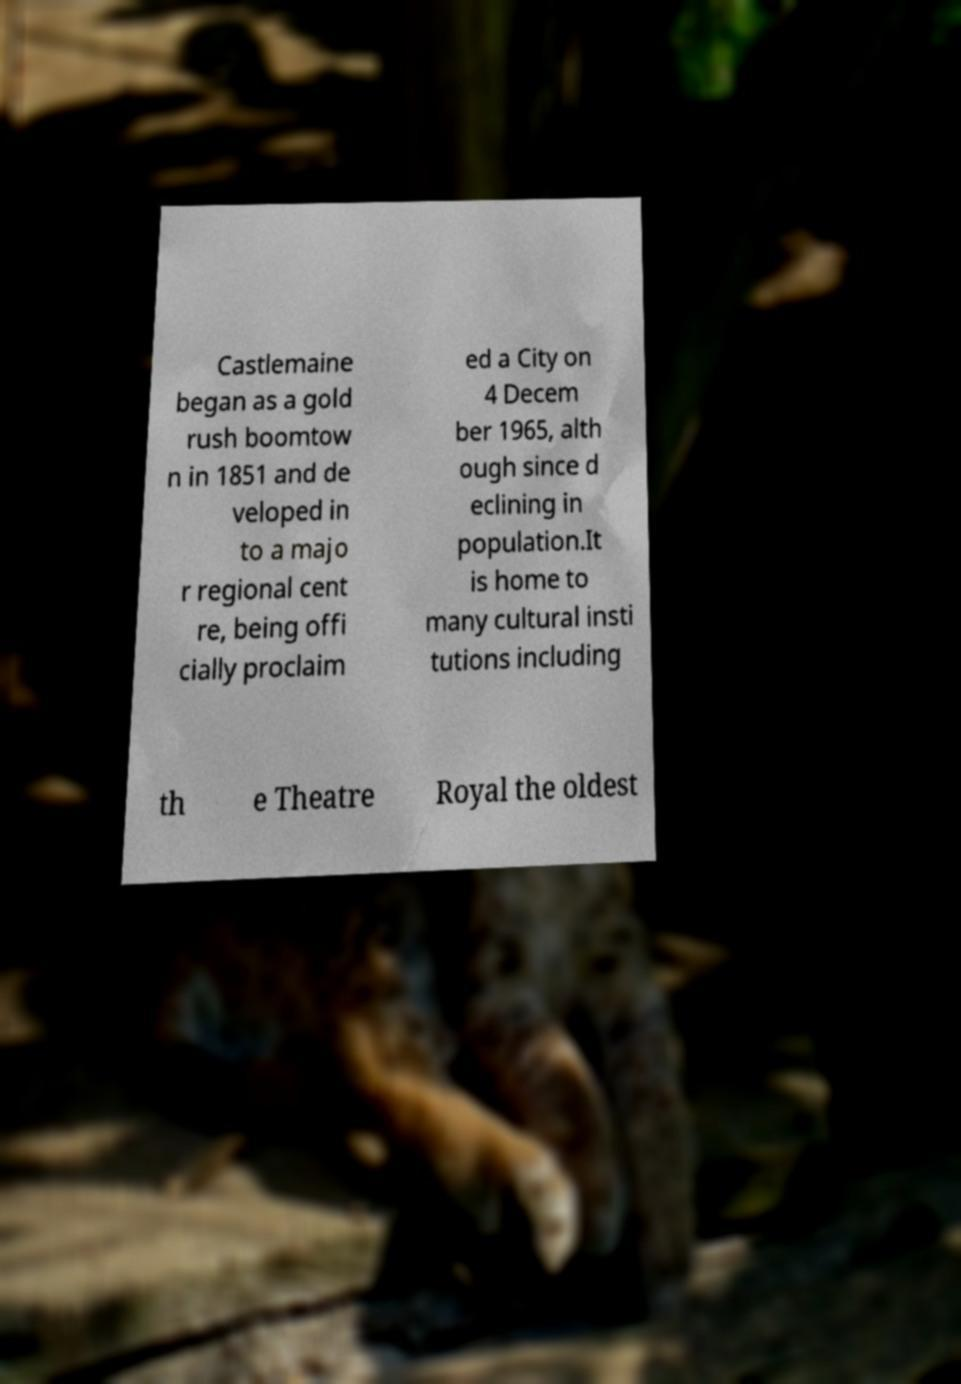There's text embedded in this image that I need extracted. Can you transcribe it verbatim? Castlemaine began as a gold rush boomtow n in 1851 and de veloped in to a majo r regional cent re, being offi cially proclaim ed a City on 4 Decem ber 1965, alth ough since d eclining in population.It is home to many cultural insti tutions including th e Theatre Royal the oldest 